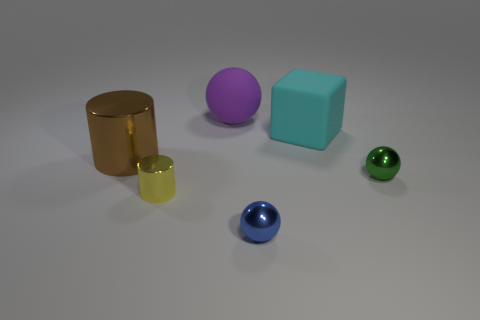Are there any other things that are the same shape as the cyan rubber thing?
Your response must be concise. No. Is the number of tiny cylinders behind the cyan cube less than the number of small green shiny things in front of the large purple matte ball?
Provide a succinct answer. Yes. How many small blue balls have the same material as the yellow cylinder?
Provide a short and direct response. 1. There is a blue shiny thing; is it the same size as the sphere behind the large brown metal thing?
Your answer should be compact. No. What is the size of the purple object left of the metal thing that is in front of the tiny thing that is to the left of the large sphere?
Your answer should be very brief. Large. Are there more yellow shiny cylinders in front of the block than purple objects that are left of the yellow cylinder?
Give a very brief answer. Yes. What number of small cylinders are behind the thing that is in front of the yellow metallic cylinder?
Provide a succinct answer. 1. Do the brown metal cylinder and the block have the same size?
Your response must be concise. Yes. What is the big thing left of the sphere behind the brown cylinder made of?
Ensure brevity in your answer.  Metal. What is the material of the big thing that is the same shape as the small green thing?
Give a very brief answer. Rubber. 